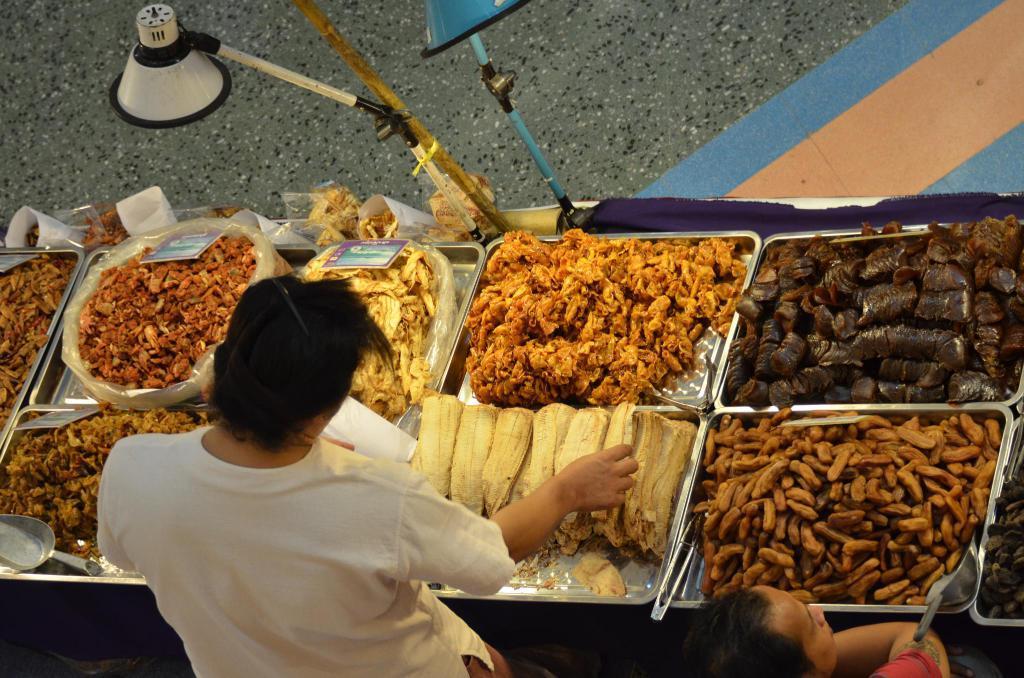In one or two sentences, can you explain what this image depicts? In this picture there is a table in the center of the image, which contains food items in the trays and there are people at the bottom side of the image and there are lamps and a bamboo at the top side of the image. 